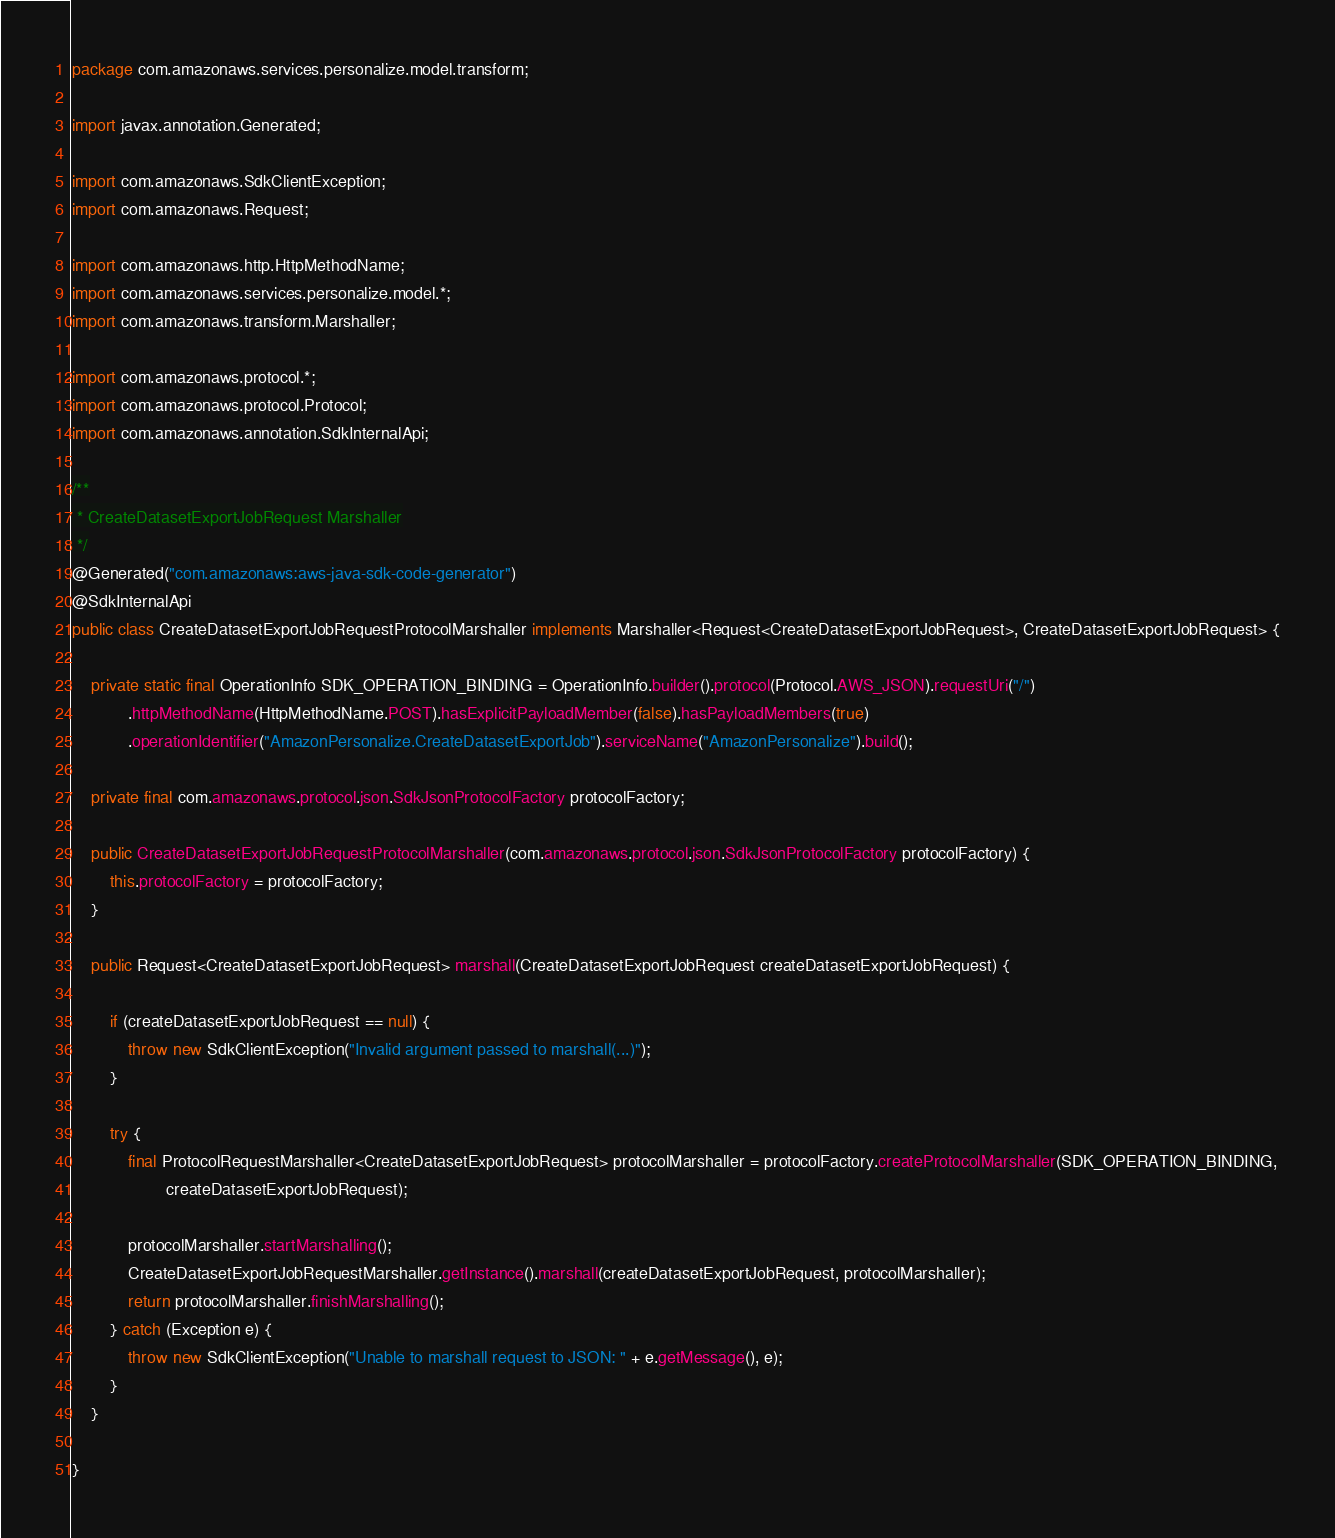Convert code to text. <code><loc_0><loc_0><loc_500><loc_500><_Java_>package com.amazonaws.services.personalize.model.transform;

import javax.annotation.Generated;

import com.amazonaws.SdkClientException;
import com.amazonaws.Request;

import com.amazonaws.http.HttpMethodName;
import com.amazonaws.services.personalize.model.*;
import com.amazonaws.transform.Marshaller;

import com.amazonaws.protocol.*;
import com.amazonaws.protocol.Protocol;
import com.amazonaws.annotation.SdkInternalApi;

/**
 * CreateDatasetExportJobRequest Marshaller
 */
@Generated("com.amazonaws:aws-java-sdk-code-generator")
@SdkInternalApi
public class CreateDatasetExportJobRequestProtocolMarshaller implements Marshaller<Request<CreateDatasetExportJobRequest>, CreateDatasetExportJobRequest> {

    private static final OperationInfo SDK_OPERATION_BINDING = OperationInfo.builder().protocol(Protocol.AWS_JSON).requestUri("/")
            .httpMethodName(HttpMethodName.POST).hasExplicitPayloadMember(false).hasPayloadMembers(true)
            .operationIdentifier("AmazonPersonalize.CreateDatasetExportJob").serviceName("AmazonPersonalize").build();

    private final com.amazonaws.protocol.json.SdkJsonProtocolFactory protocolFactory;

    public CreateDatasetExportJobRequestProtocolMarshaller(com.amazonaws.protocol.json.SdkJsonProtocolFactory protocolFactory) {
        this.protocolFactory = protocolFactory;
    }

    public Request<CreateDatasetExportJobRequest> marshall(CreateDatasetExportJobRequest createDatasetExportJobRequest) {

        if (createDatasetExportJobRequest == null) {
            throw new SdkClientException("Invalid argument passed to marshall(...)");
        }

        try {
            final ProtocolRequestMarshaller<CreateDatasetExportJobRequest> protocolMarshaller = protocolFactory.createProtocolMarshaller(SDK_OPERATION_BINDING,
                    createDatasetExportJobRequest);

            protocolMarshaller.startMarshalling();
            CreateDatasetExportJobRequestMarshaller.getInstance().marshall(createDatasetExportJobRequest, protocolMarshaller);
            return protocolMarshaller.finishMarshalling();
        } catch (Exception e) {
            throw new SdkClientException("Unable to marshall request to JSON: " + e.getMessage(), e);
        }
    }

}
</code> 